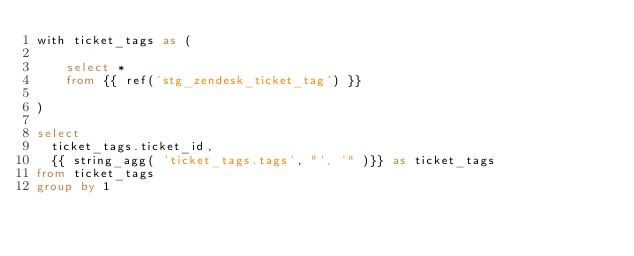Convert code to text. <code><loc_0><loc_0><loc_500><loc_500><_SQL_>with ticket_tags as (

    select *
    from {{ ref('stg_zendesk_ticket_tag') }}
  
)

select
  ticket_tags.ticket_id,
  {{ string_agg( 'ticket_tags.tags', "', '" )}} as ticket_tags
from ticket_tags
group by 1</code> 